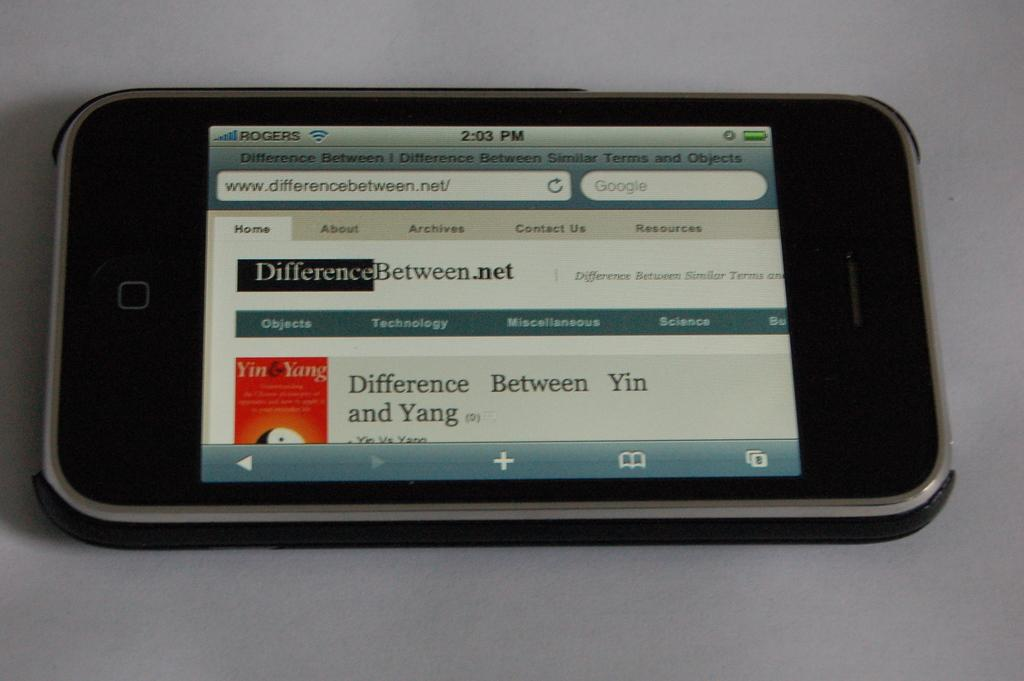<image>
Describe the image concisely. A smart phone with the website www.differencebetween.net on it's browser. 